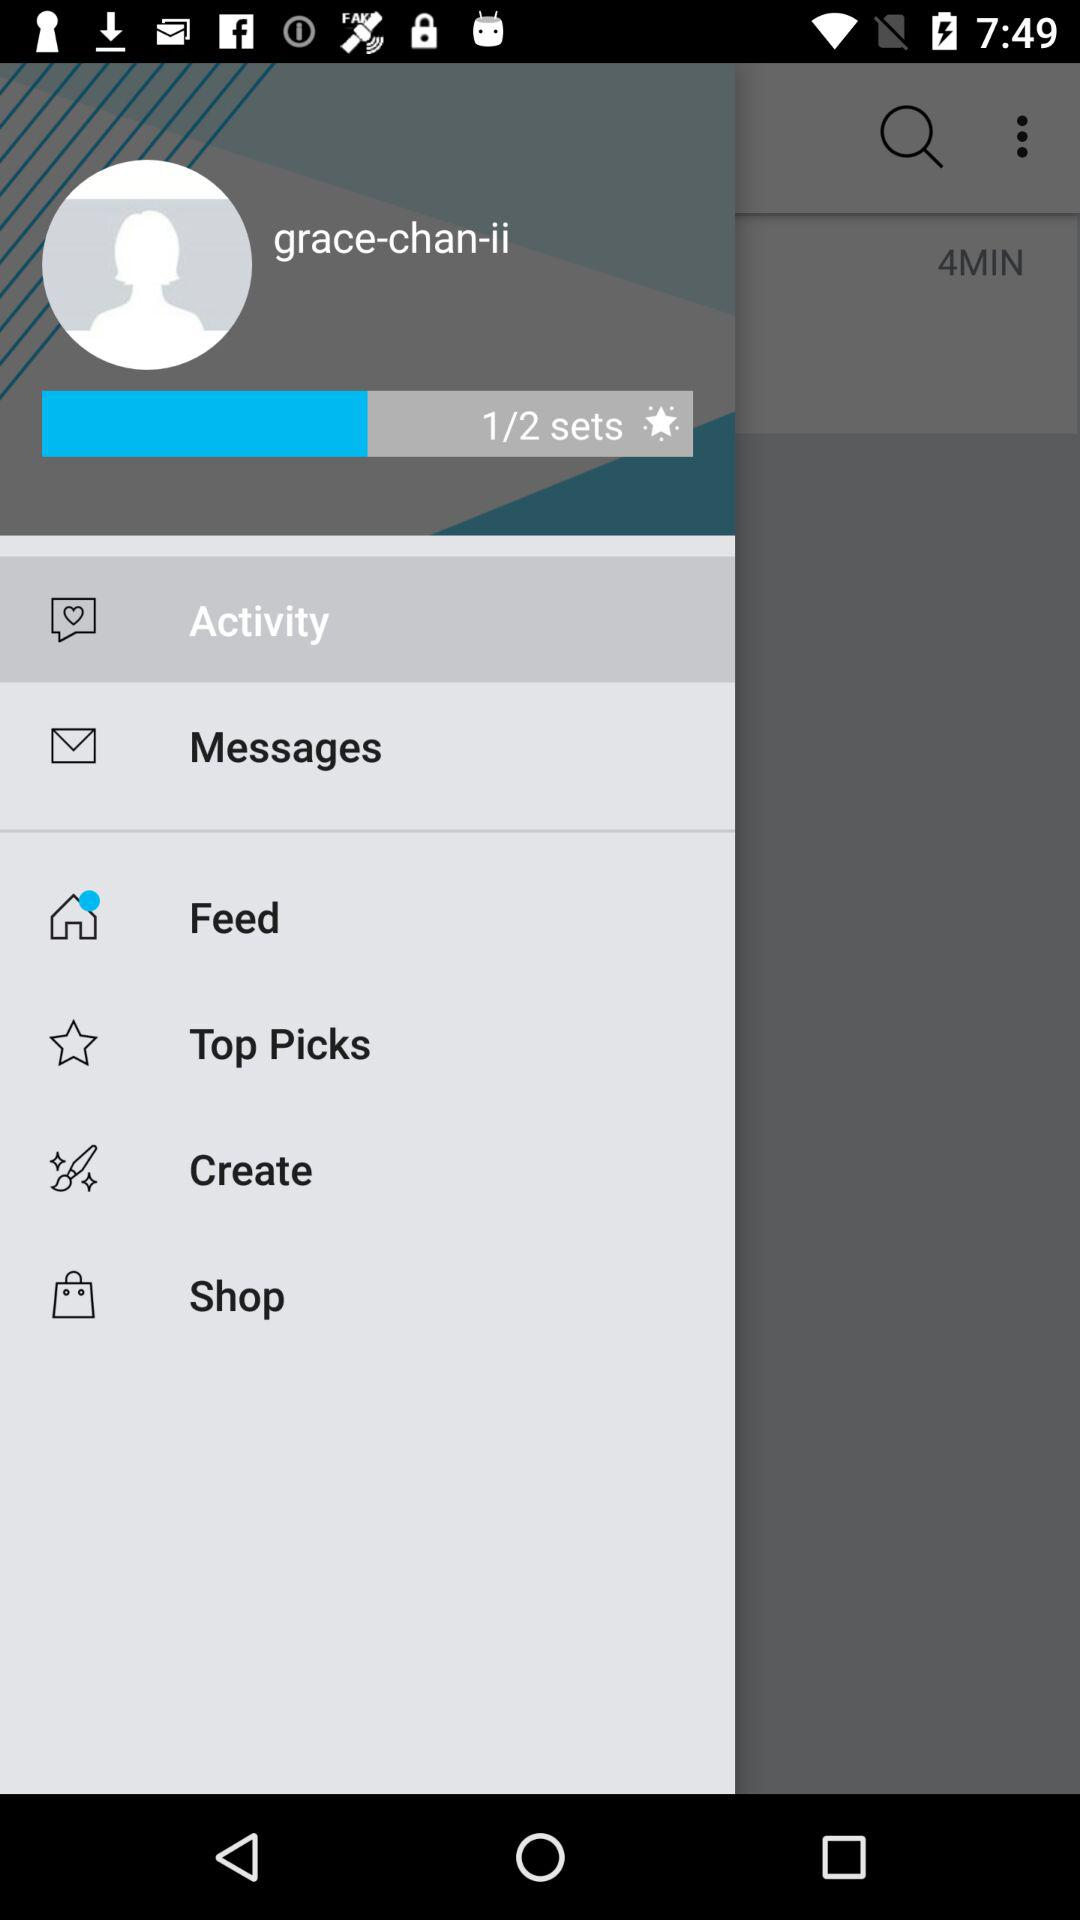Which item is selected? The selected item is "Activity". 